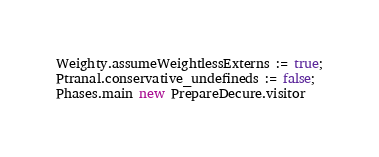<code> <loc_0><loc_0><loc_500><loc_500><_OCaml_>Weighty.assumeWeightlessExterns := true;
Ptranal.conservative_undefineds := false;
Phases.main new PrepareDecure.visitor
</code> 